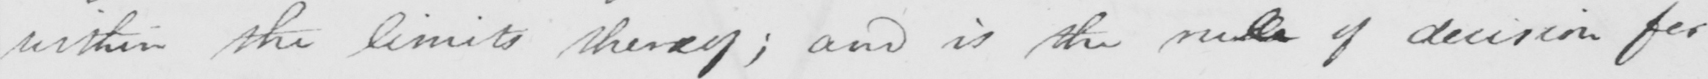What is written in this line of handwriting? within the limits thereof ; and is the rule of decision for 